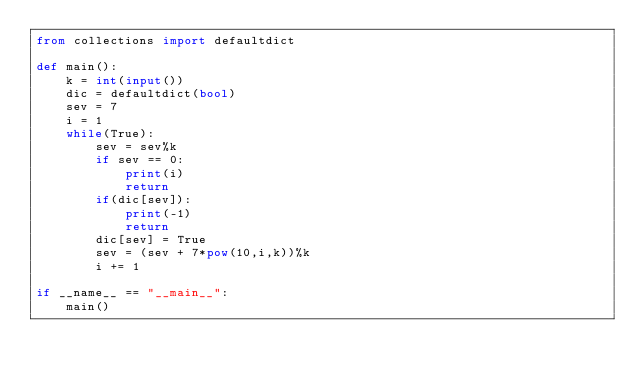<code> <loc_0><loc_0><loc_500><loc_500><_Python_>from collections import defaultdict

def main():
    k = int(input())
    dic = defaultdict(bool)
    sev = 7
    i = 1
    while(True):
        sev = sev%k
        if sev == 0:
            print(i)
            return
        if(dic[sev]):
            print(-1)
            return
        dic[sev] = True
        sev = (sev + 7*pow(10,i,k))%k
        i += 1

if __name__ == "__main__":
    main()</code> 